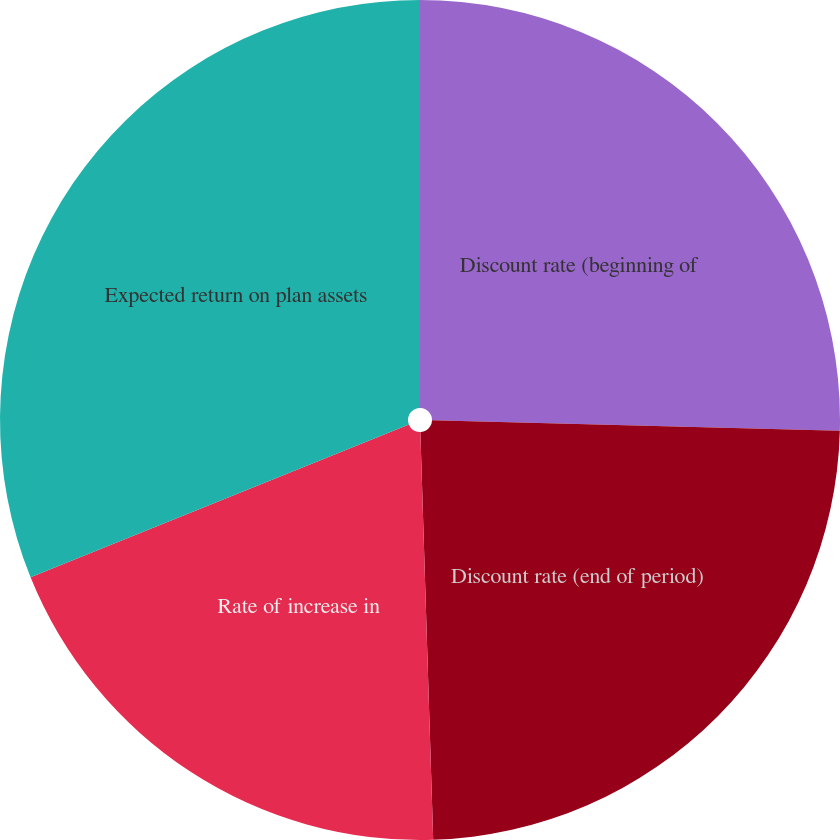Convert chart. <chart><loc_0><loc_0><loc_500><loc_500><pie_chart><fcel>Discount rate (beginning of<fcel>Discount rate (end of period)<fcel>Rate of increase in<fcel>Expected return on plan assets<nl><fcel>25.41%<fcel>24.09%<fcel>19.39%<fcel>31.11%<nl></chart> 